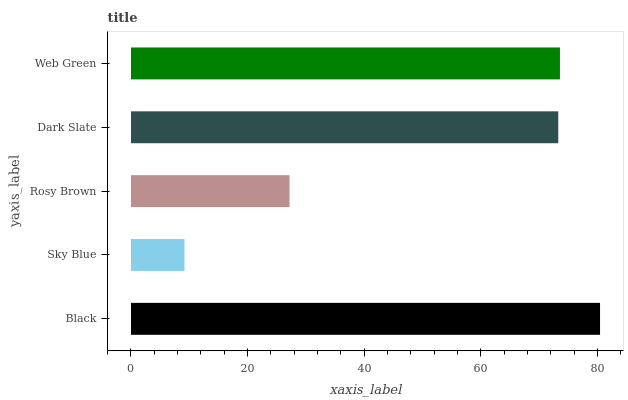Is Sky Blue the minimum?
Answer yes or no. Yes. Is Black the maximum?
Answer yes or no. Yes. Is Rosy Brown the minimum?
Answer yes or no. No. Is Rosy Brown the maximum?
Answer yes or no. No. Is Rosy Brown greater than Sky Blue?
Answer yes or no. Yes. Is Sky Blue less than Rosy Brown?
Answer yes or no. Yes. Is Sky Blue greater than Rosy Brown?
Answer yes or no. No. Is Rosy Brown less than Sky Blue?
Answer yes or no. No. Is Dark Slate the high median?
Answer yes or no. Yes. Is Dark Slate the low median?
Answer yes or no. Yes. Is Web Green the high median?
Answer yes or no. No. Is Black the low median?
Answer yes or no. No. 